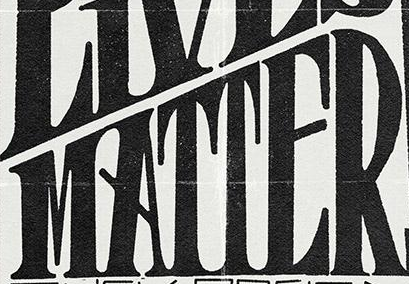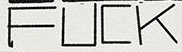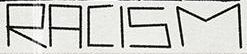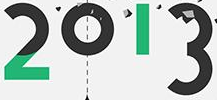What words can you see in these images in sequence, separated by a semicolon? MATTER; FUCK; RACISM; 2013 